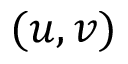<formula> <loc_0><loc_0><loc_500><loc_500>( u , v )</formula> 